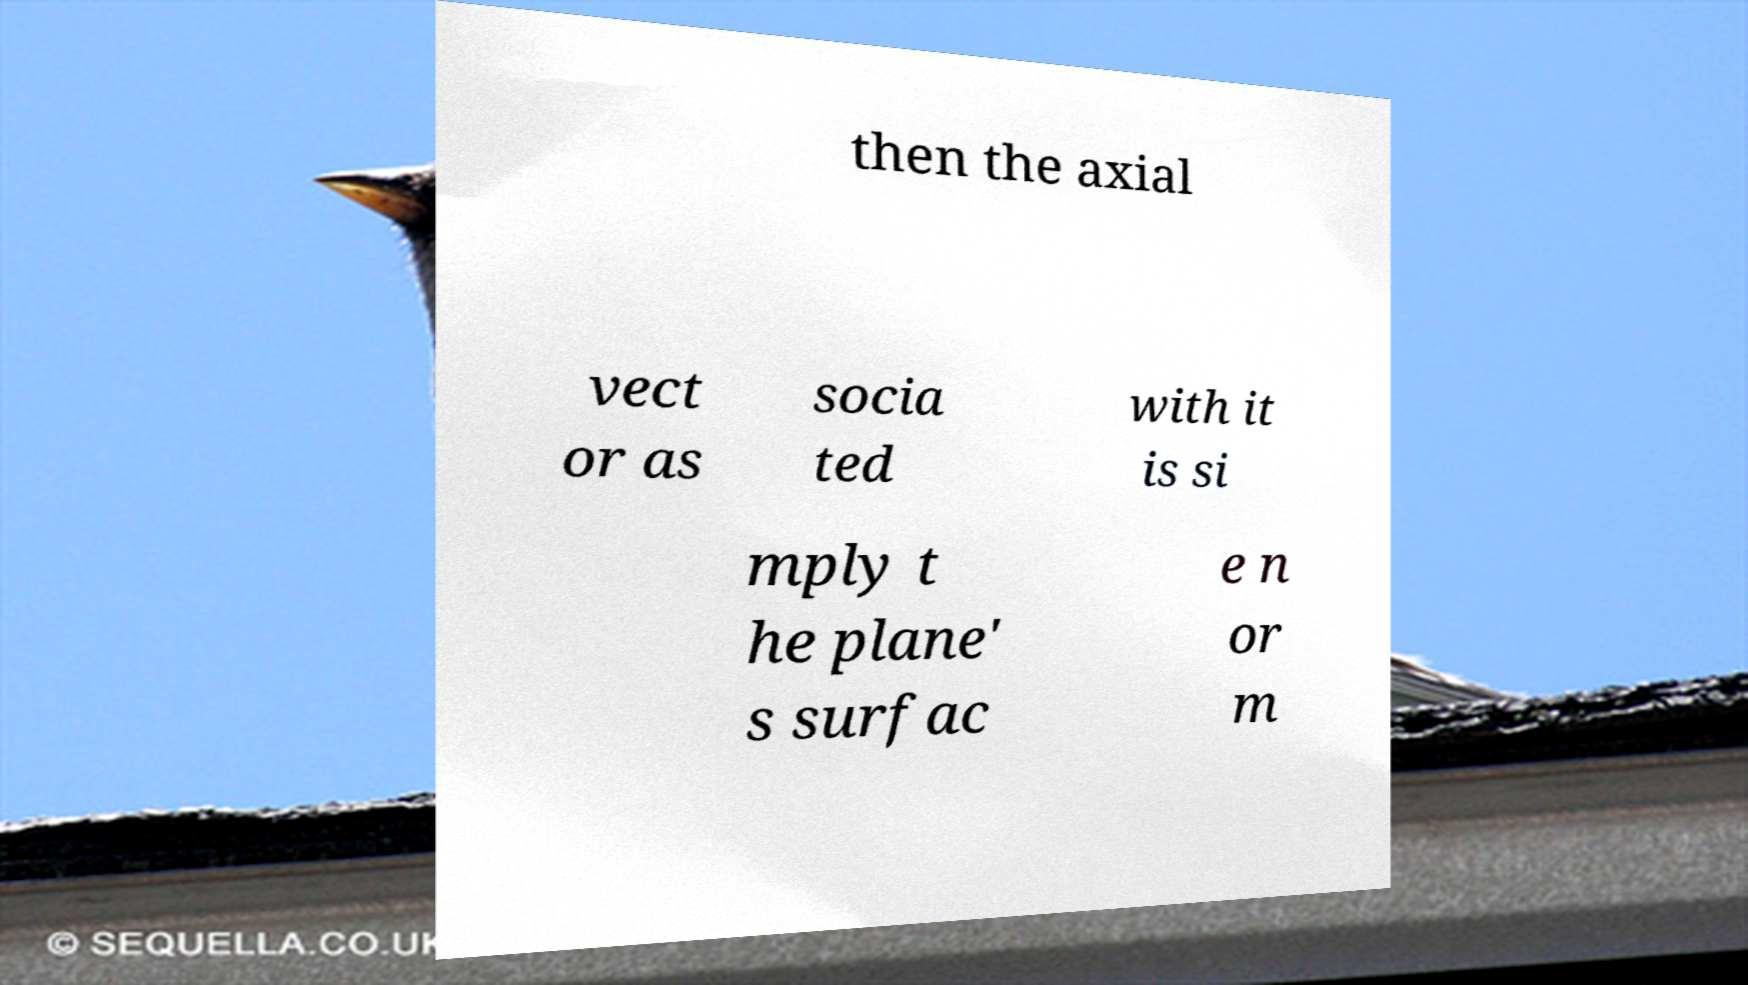Please identify and transcribe the text found in this image. then the axial vect or as socia ted with it is si mply t he plane' s surfac e n or m 